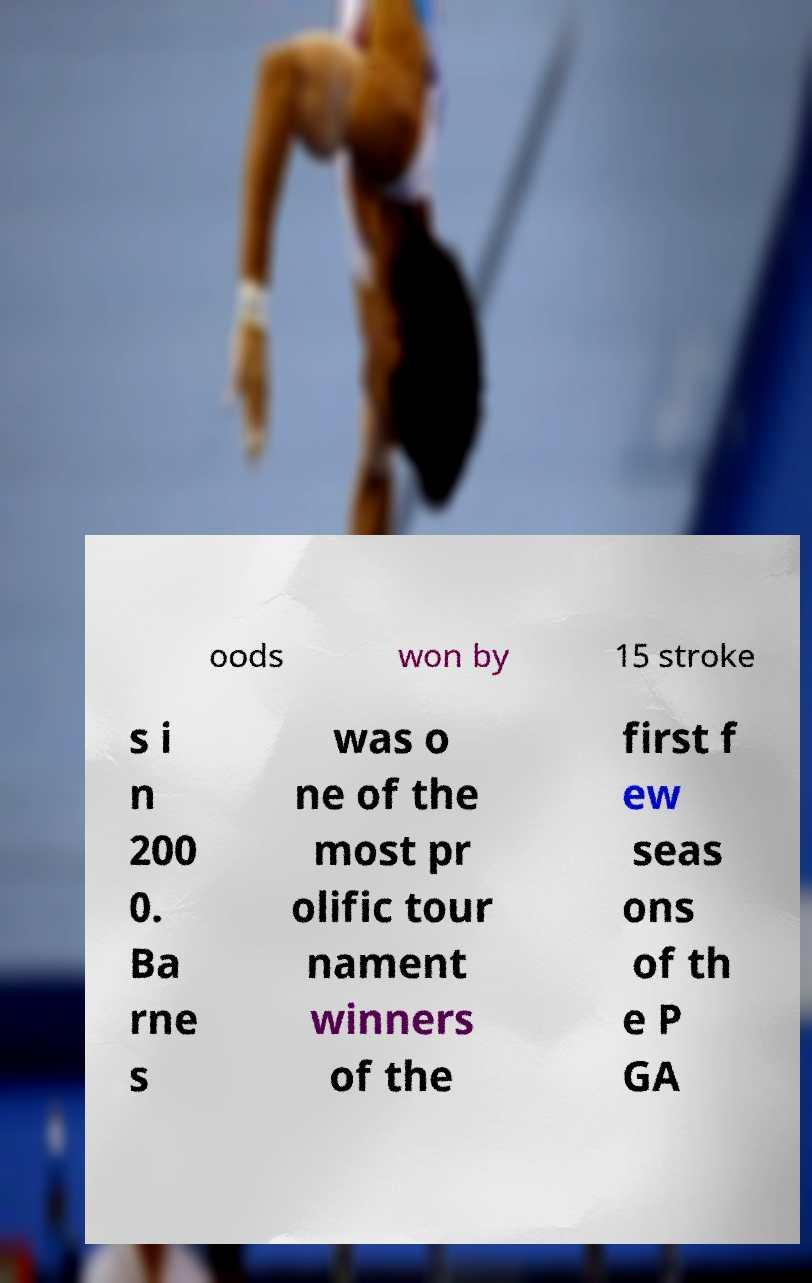Can you accurately transcribe the text from the provided image for me? oods won by 15 stroke s i n 200 0. Ba rne s was o ne of the most pr olific tour nament winners of the first f ew seas ons of th e P GA 